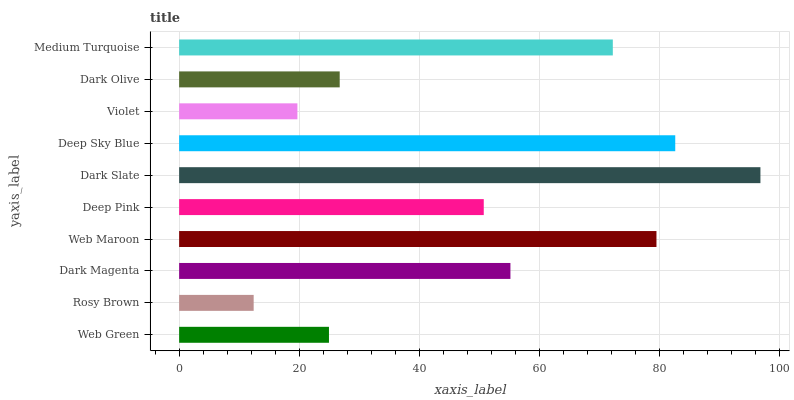Is Rosy Brown the minimum?
Answer yes or no. Yes. Is Dark Slate the maximum?
Answer yes or no. Yes. Is Dark Magenta the minimum?
Answer yes or no. No. Is Dark Magenta the maximum?
Answer yes or no. No. Is Dark Magenta greater than Rosy Brown?
Answer yes or no. Yes. Is Rosy Brown less than Dark Magenta?
Answer yes or no. Yes. Is Rosy Brown greater than Dark Magenta?
Answer yes or no. No. Is Dark Magenta less than Rosy Brown?
Answer yes or no. No. Is Dark Magenta the high median?
Answer yes or no. Yes. Is Deep Pink the low median?
Answer yes or no. Yes. Is Web Green the high median?
Answer yes or no. No. Is Web Green the low median?
Answer yes or no. No. 